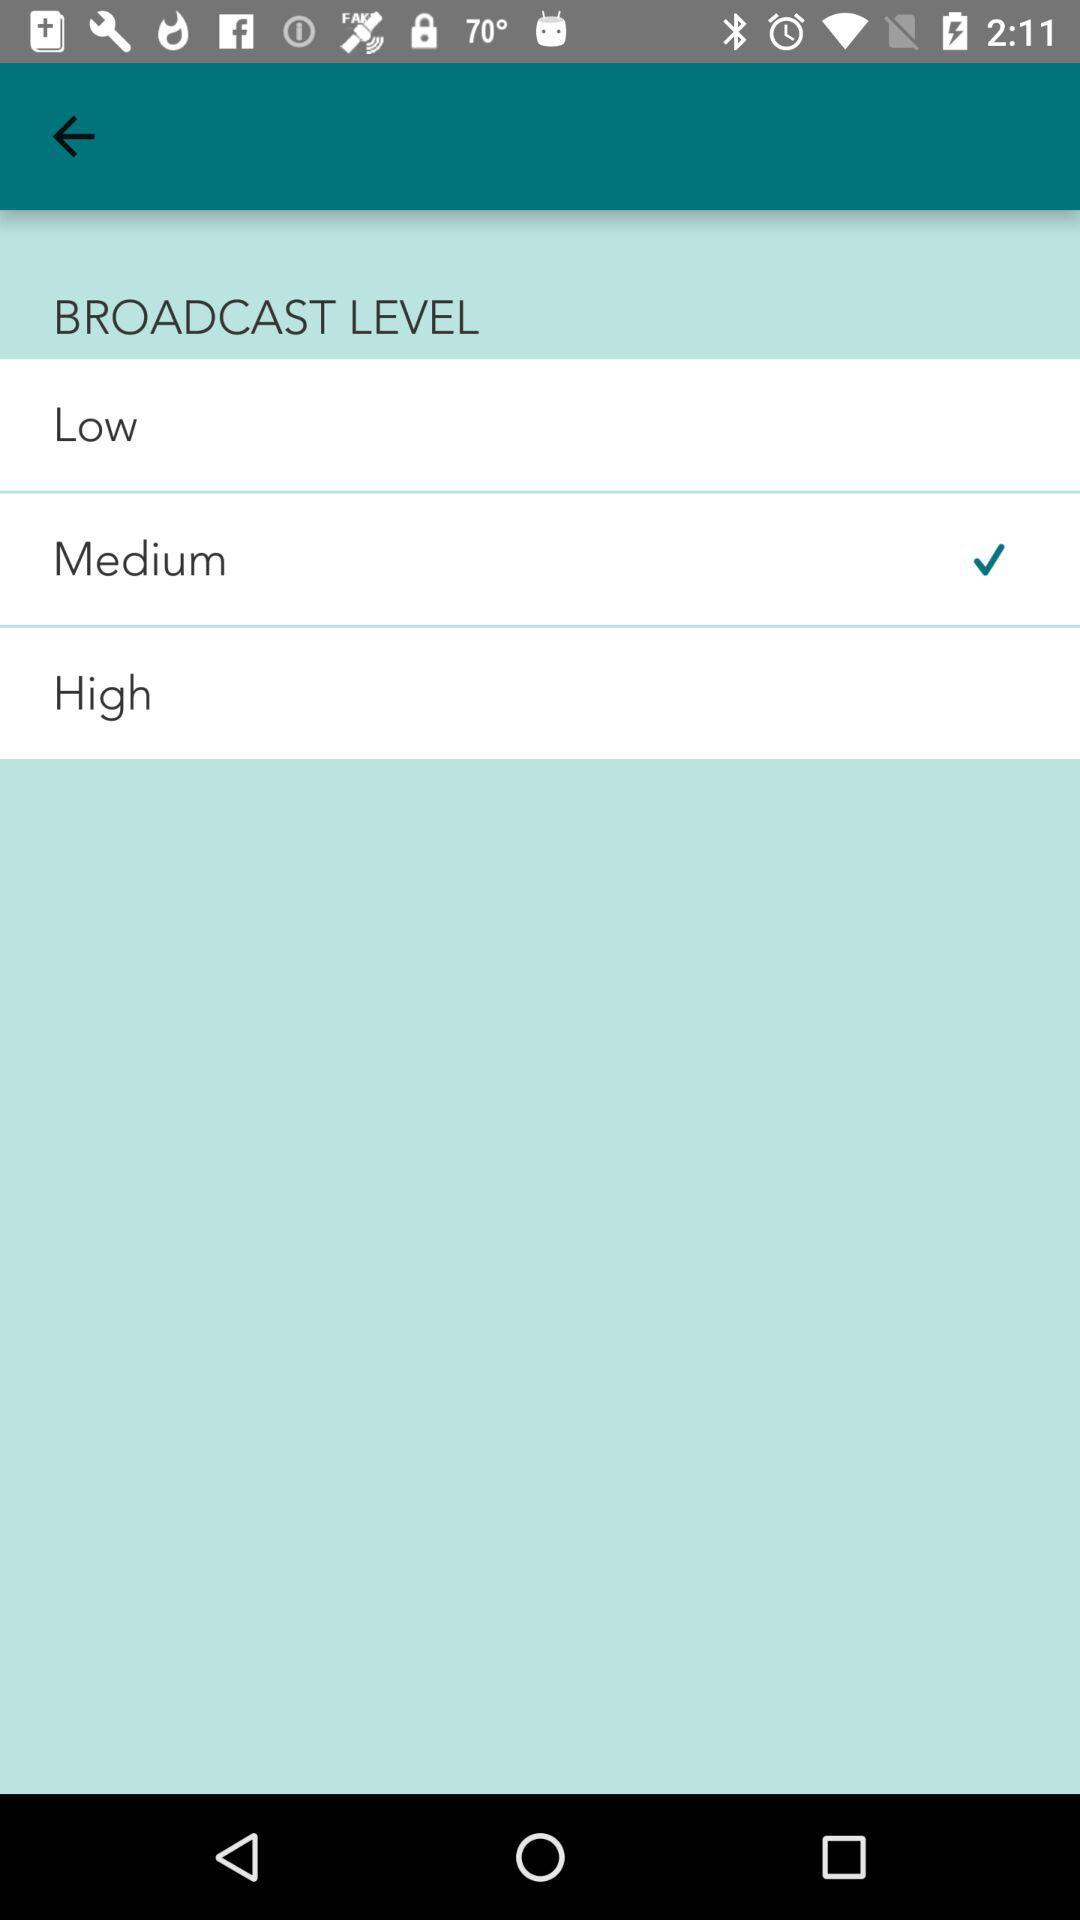Which level is checked: low, medium, or high?
Answer the question using a single word or phrase. Medium 